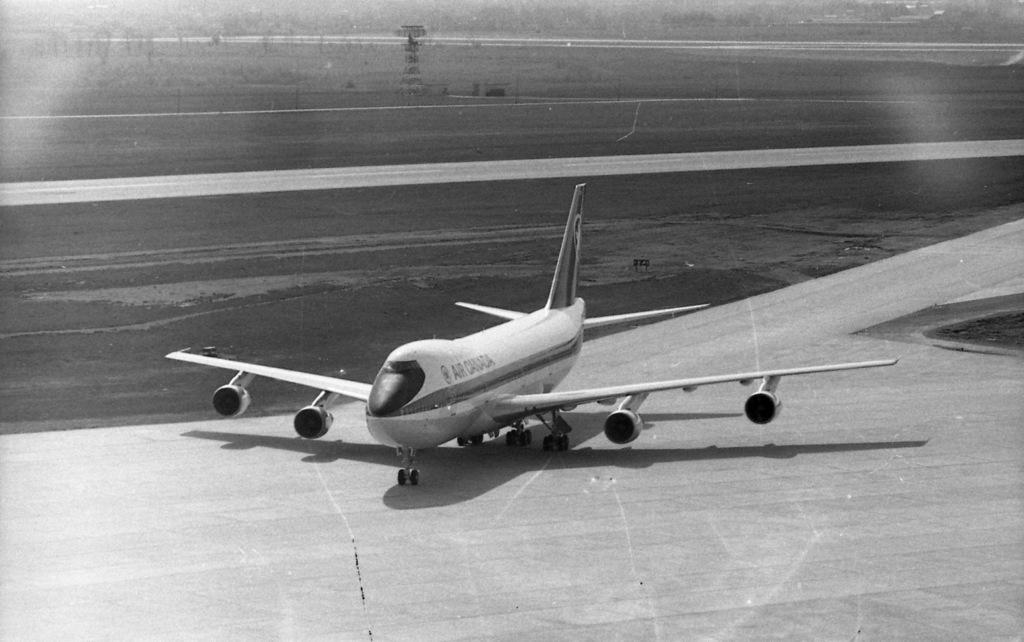What is the name of this airline?
Offer a terse response. Air canada. 